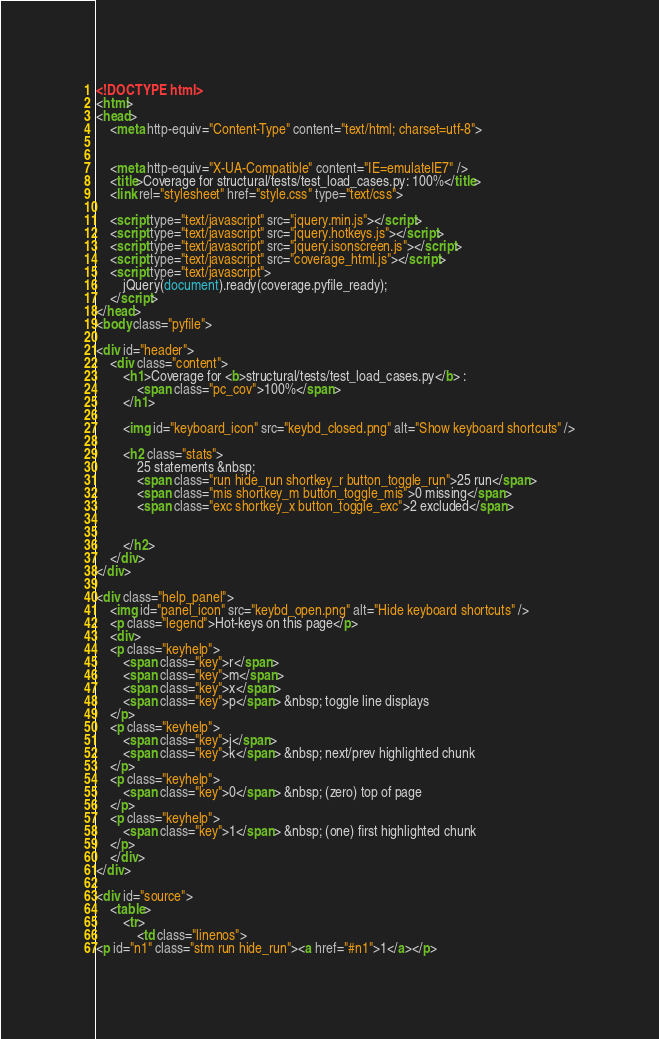<code> <loc_0><loc_0><loc_500><loc_500><_HTML_>


<!DOCTYPE html>
<html>
<head>
    <meta http-equiv="Content-Type" content="text/html; charset=utf-8">
    
    
    <meta http-equiv="X-UA-Compatible" content="IE=emulateIE7" />
    <title>Coverage for structural/tests/test_load_cases.py: 100%</title>
    <link rel="stylesheet" href="style.css" type="text/css">
    
    <script type="text/javascript" src="jquery.min.js"></script>
    <script type="text/javascript" src="jquery.hotkeys.js"></script>
    <script type="text/javascript" src="jquery.isonscreen.js"></script>
    <script type="text/javascript" src="coverage_html.js"></script>
    <script type="text/javascript">
        jQuery(document).ready(coverage.pyfile_ready);
    </script>
</head>
<body class="pyfile">

<div id="header">
    <div class="content">
        <h1>Coverage for <b>structural/tests/test_load_cases.py</b> :
            <span class="pc_cov">100%</span>
        </h1>

        <img id="keyboard_icon" src="keybd_closed.png" alt="Show keyboard shortcuts" />

        <h2 class="stats">
            25 statements &nbsp;
            <span class="run hide_run shortkey_r button_toggle_run">25 run</span>
            <span class="mis shortkey_m button_toggle_mis">0 missing</span>
            <span class="exc shortkey_x button_toggle_exc">2 excluded</span>

            
        </h2>
    </div>
</div>

<div class="help_panel">
    <img id="panel_icon" src="keybd_open.png" alt="Hide keyboard shortcuts" />
    <p class="legend">Hot-keys on this page</p>
    <div>
    <p class="keyhelp">
        <span class="key">r</span>
        <span class="key">m</span>
        <span class="key">x</span>
        <span class="key">p</span> &nbsp; toggle line displays
    </p>
    <p class="keyhelp">
        <span class="key">j</span>
        <span class="key">k</span> &nbsp; next/prev highlighted chunk
    </p>
    <p class="keyhelp">
        <span class="key">0</span> &nbsp; (zero) top of page
    </p>
    <p class="keyhelp">
        <span class="key">1</span> &nbsp; (one) first highlighted chunk
    </p>
    </div>
</div>

<div id="source">
    <table>
        <tr>
            <td class="linenos">
<p id="n1" class="stm run hide_run"><a href="#n1">1</a></p></code> 